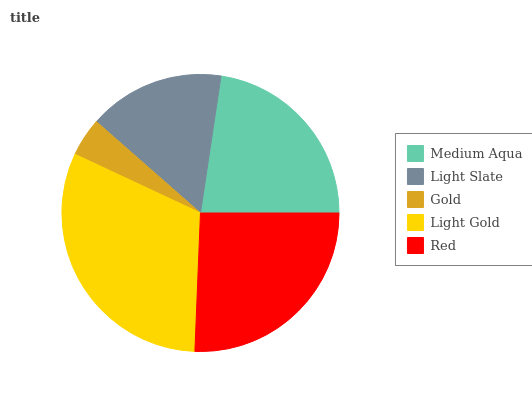Is Gold the minimum?
Answer yes or no. Yes. Is Light Gold the maximum?
Answer yes or no. Yes. Is Light Slate the minimum?
Answer yes or no. No. Is Light Slate the maximum?
Answer yes or no. No. Is Medium Aqua greater than Light Slate?
Answer yes or no. Yes. Is Light Slate less than Medium Aqua?
Answer yes or no. Yes. Is Light Slate greater than Medium Aqua?
Answer yes or no. No. Is Medium Aqua less than Light Slate?
Answer yes or no. No. Is Medium Aqua the high median?
Answer yes or no. Yes. Is Medium Aqua the low median?
Answer yes or no. Yes. Is Light Gold the high median?
Answer yes or no. No. Is Light Slate the low median?
Answer yes or no. No. 